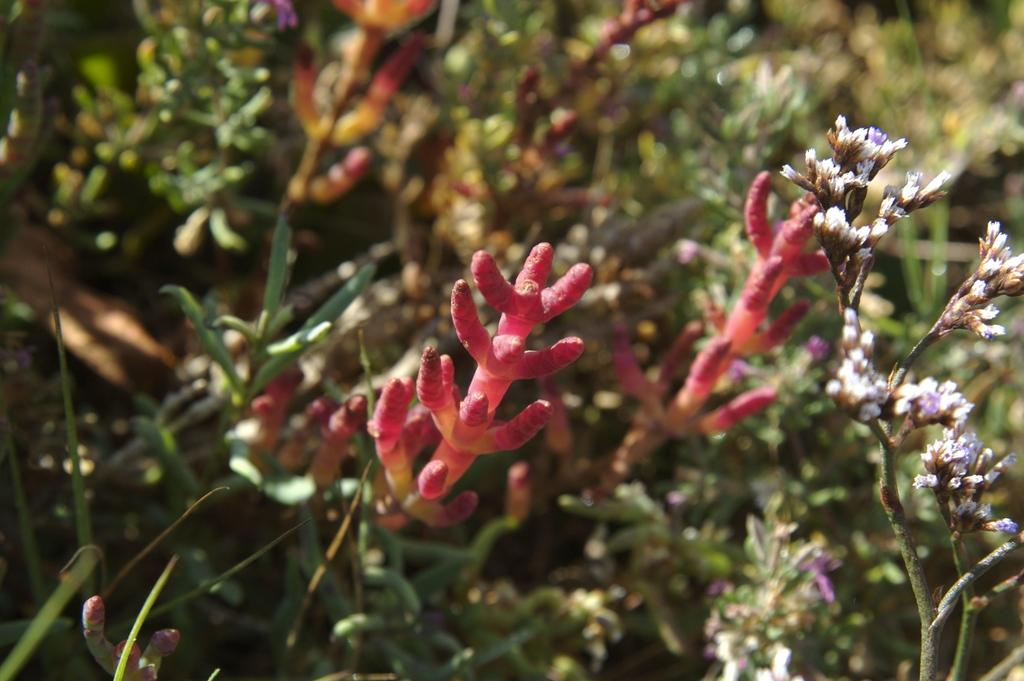What types of living organisms can be seen in the image? Fruits and flowers are visible in the image. What part of the plants can be seen in the image? There are stems of plants in the image. What type of apparel is the goldfish wearing in the image? There is no goldfish present in the image, and therefore no apparel can be observed. 